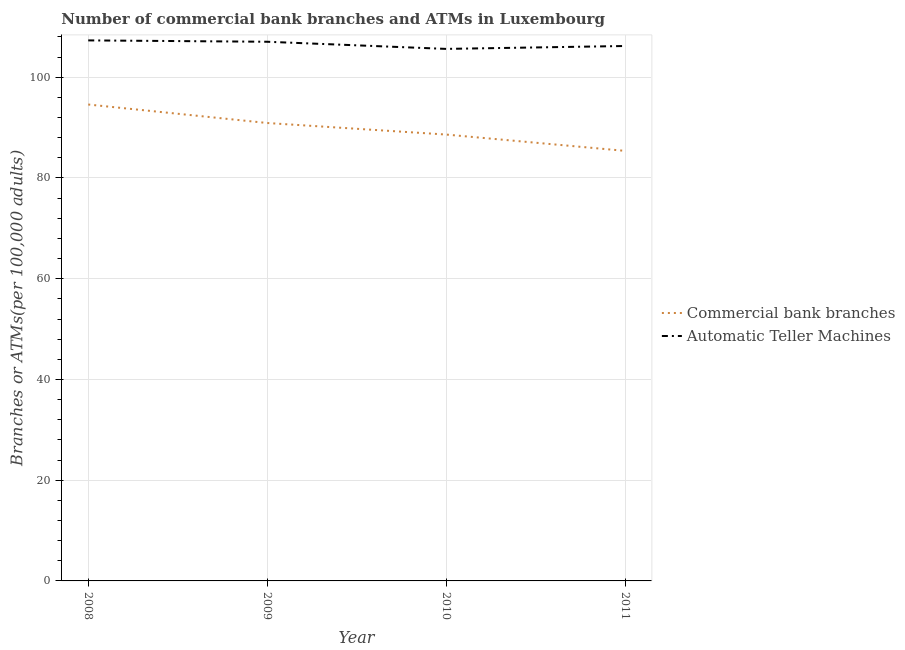Does the line corresponding to number of commercal bank branches intersect with the line corresponding to number of atms?
Your answer should be very brief. No. What is the number of atms in 2009?
Offer a terse response. 107.05. Across all years, what is the maximum number of atms?
Give a very brief answer. 107.32. Across all years, what is the minimum number of atms?
Keep it short and to the point. 105.63. In which year was the number of atms maximum?
Your response must be concise. 2008. What is the total number of atms in the graph?
Offer a terse response. 426.19. What is the difference between the number of atms in 2009 and that in 2011?
Provide a succinct answer. 0.84. What is the difference between the number of commercal bank branches in 2011 and the number of atms in 2009?
Offer a very short reply. -21.66. What is the average number of atms per year?
Your answer should be compact. 106.55. In the year 2009, what is the difference between the number of commercal bank branches and number of atms?
Offer a very short reply. -16.13. What is the ratio of the number of atms in 2008 to that in 2009?
Make the answer very short. 1. Is the number of atms in 2009 less than that in 2011?
Provide a succinct answer. No. Is the difference between the number of atms in 2008 and 2011 greater than the difference between the number of commercal bank branches in 2008 and 2011?
Your response must be concise. No. What is the difference between the highest and the second highest number of commercal bank branches?
Your answer should be compact. 3.67. What is the difference between the highest and the lowest number of commercal bank branches?
Ensure brevity in your answer.  9.2. Is the number of atms strictly greater than the number of commercal bank branches over the years?
Ensure brevity in your answer.  Yes. Is the number of atms strictly less than the number of commercal bank branches over the years?
Offer a terse response. No. How many years are there in the graph?
Make the answer very short. 4. Are the values on the major ticks of Y-axis written in scientific E-notation?
Your response must be concise. No. Does the graph contain any zero values?
Your answer should be very brief. No. Where does the legend appear in the graph?
Offer a terse response. Center right. How are the legend labels stacked?
Give a very brief answer. Vertical. What is the title of the graph?
Your answer should be very brief. Number of commercial bank branches and ATMs in Luxembourg. Does "Private credit bureau" appear as one of the legend labels in the graph?
Keep it short and to the point. No. What is the label or title of the X-axis?
Your response must be concise. Year. What is the label or title of the Y-axis?
Offer a very short reply. Branches or ATMs(per 100,0 adults). What is the Branches or ATMs(per 100,000 adults) in Commercial bank branches in 2008?
Offer a very short reply. 94.59. What is the Branches or ATMs(per 100,000 adults) of Automatic Teller Machines in 2008?
Offer a terse response. 107.32. What is the Branches or ATMs(per 100,000 adults) of Commercial bank branches in 2009?
Provide a short and direct response. 90.92. What is the Branches or ATMs(per 100,000 adults) in Automatic Teller Machines in 2009?
Your answer should be very brief. 107.05. What is the Branches or ATMs(per 100,000 adults) in Commercial bank branches in 2010?
Ensure brevity in your answer.  88.62. What is the Branches or ATMs(per 100,000 adults) in Automatic Teller Machines in 2010?
Ensure brevity in your answer.  105.63. What is the Branches or ATMs(per 100,000 adults) of Commercial bank branches in 2011?
Give a very brief answer. 85.38. What is the Branches or ATMs(per 100,000 adults) in Automatic Teller Machines in 2011?
Make the answer very short. 106.2. Across all years, what is the maximum Branches or ATMs(per 100,000 adults) of Commercial bank branches?
Give a very brief answer. 94.59. Across all years, what is the maximum Branches or ATMs(per 100,000 adults) of Automatic Teller Machines?
Provide a succinct answer. 107.32. Across all years, what is the minimum Branches or ATMs(per 100,000 adults) of Commercial bank branches?
Provide a short and direct response. 85.38. Across all years, what is the minimum Branches or ATMs(per 100,000 adults) in Automatic Teller Machines?
Your answer should be very brief. 105.63. What is the total Branches or ATMs(per 100,000 adults) in Commercial bank branches in the graph?
Your answer should be compact. 359.51. What is the total Branches or ATMs(per 100,000 adults) of Automatic Teller Machines in the graph?
Keep it short and to the point. 426.19. What is the difference between the Branches or ATMs(per 100,000 adults) of Commercial bank branches in 2008 and that in 2009?
Your response must be concise. 3.67. What is the difference between the Branches or ATMs(per 100,000 adults) in Automatic Teller Machines in 2008 and that in 2009?
Offer a terse response. 0.27. What is the difference between the Branches or ATMs(per 100,000 adults) of Commercial bank branches in 2008 and that in 2010?
Make the answer very short. 5.97. What is the difference between the Branches or ATMs(per 100,000 adults) in Automatic Teller Machines in 2008 and that in 2010?
Offer a very short reply. 1.69. What is the difference between the Branches or ATMs(per 100,000 adults) in Commercial bank branches in 2008 and that in 2011?
Provide a succinct answer. 9.2. What is the difference between the Branches or ATMs(per 100,000 adults) in Commercial bank branches in 2009 and that in 2010?
Keep it short and to the point. 2.29. What is the difference between the Branches or ATMs(per 100,000 adults) of Automatic Teller Machines in 2009 and that in 2010?
Offer a very short reply. 1.42. What is the difference between the Branches or ATMs(per 100,000 adults) in Commercial bank branches in 2009 and that in 2011?
Your answer should be very brief. 5.53. What is the difference between the Branches or ATMs(per 100,000 adults) of Automatic Teller Machines in 2009 and that in 2011?
Offer a terse response. 0.84. What is the difference between the Branches or ATMs(per 100,000 adults) of Commercial bank branches in 2010 and that in 2011?
Provide a short and direct response. 3.24. What is the difference between the Branches or ATMs(per 100,000 adults) in Automatic Teller Machines in 2010 and that in 2011?
Give a very brief answer. -0.58. What is the difference between the Branches or ATMs(per 100,000 adults) of Commercial bank branches in 2008 and the Branches or ATMs(per 100,000 adults) of Automatic Teller Machines in 2009?
Give a very brief answer. -12.46. What is the difference between the Branches or ATMs(per 100,000 adults) of Commercial bank branches in 2008 and the Branches or ATMs(per 100,000 adults) of Automatic Teller Machines in 2010?
Your answer should be compact. -11.04. What is the difference between the Branches or ATMs(per 100,000 adults) of Commercial bank branches in 2008 and the Branches or ATMs(per 100,000 adults) of Automatic Teller Machines in 2011?
Your answer should be very brief. -11.62. What is the difference between the Branches or ATMs(per 100,000 adults) of Commercial bank branches in 2009 and the Branches or ATMs(per 100,000 adults) of Automatic Teller Machines in 2010?
Your answer should be compact. -14.71. What is the difference between the Branches or ATMs(per 100,000 adults) in Commercial bank branches in 2009 and the Branches or ATMs(per 100,000 adults) in Automatic Teller Machines in 2011?
Provide a succinct answer. -15.29. What is the difference between the Branches or ATMs(per 100,000 adults) of Commercial bank branches in 2010 and the Branches or ATMs(per 100,000 adults) of Automatic Teller Machines in 2011?
Your answer should be very brief. -17.58. What is the average Branches or ATMs(per 100,000 adults) in Commercial bank branches per year?
Keep it short and to the point. 89.88. What is the average Branches or ATMs(per 100,000 adults) in Automatic Teller Machines per year?
Ensure brevity in your answer.  106.55. In the year 2008, what is the difference between the Branches or ATMs(per 100,000 adults) of Commercial bank branches and Branches or ATMs(per 100,000 adults) of Automatic Teller Machines?
Your answer should be very brief. -12.73. In the year 2009, what is the difference between the Branches or ATMs(per 100,000 adults) in Commercial bank branches and Branches or ATMs(per 100,000 adults) in Automatic Teller Machines?
Keep it short and to the point. -16.13. In the year 2010, what is the difference between the Branches or ATMs(per 100,000 adults) of Commercial bank branches and Branches or ATMs(per 100,000 adults) of Automatic Teller Machines?
Give a very brief answer. -17.01. In the year 2011, what is the difference between the Branches or ATMs(per 100,000 adults) in Commercial bank branches and Branches or ATMs(per 100,000 adults) in Automatic Teller Machines?
Keep it short and to the point. -20.82. What is the ratio of the Branches or ATMs(per 100,000 adults) in Commercial bank branches in 2008 to that in 2009?
Offer a terse response. 1.04. What is the ratio of the Branches or ATMs(per 100,000 adults) of Automatic Teller Machines in 2008 to that in 2009?
Your answer should be compact. 1. What is the ratio of the Branches or ATMs(per 100,000 adults) in Commercial bank branches in 2008 to that in 2010?
Make the answer very short. 1.07. What is the ratio of the Branches or ATMs(per 100,000 adults) of Commercial bank branches in 2008 to that in 2011?
Your response must be concise. 1.11. What is the ratio of the Branches or ATMs(per 100,000 adults) of Automatic Teller Machines in 2008 to that in 2011?
Keep it short and to the point. 1.01. What is the ratio of the Branches or ATMs(per 100,000 adults) of Commercial bank branches in 2009 to that in 2010?
Provide a short and direct response. 1.03. What is the ratio of the Branches or ATMs(per 100,000 adults) in Automatic Teller Machines in 2009 to that in 2010?
Your answer should be very brief. 1.01. What is the ratio of the Branches or ATMs(per 100,000 adults) of Commercial bank branches in 2009 to that in 2011?
Ensure brevity in your answer.  1.06. What is the ratio of the Branches or ATMs(per 100,000 adults) of Automatic Teller Machines in 2009 to that in 2011?
Provide a succinct answer. 1.01. What is the ratio of the Branches or ATMs(per 100,000 adults) of Commercial bank branches in 2010 to that in 2011?
Your response must be concise. 1.04. What is the difference between the highest and the second highest Branches or ATMs(per 100,000 adults) in Commercial bank branches?
Your answer should be very brief. 3.67. What is the difference between the highest and the second highest Branches or ATMs(per 100,000 adults) in Automatic Teller Machines?
Make the answer very short. 0.27. What is the difference between the highest and the lowest Branches or ATMs(per 100,000 adults) in Commercial bank branches?
Offer a terse response. 9.2. What is the difference between the highest and the lowest Branches or ATMs(per 100,000 adults) of Automatic Teller Machines?
Provide a succinct answer. 1.69. 